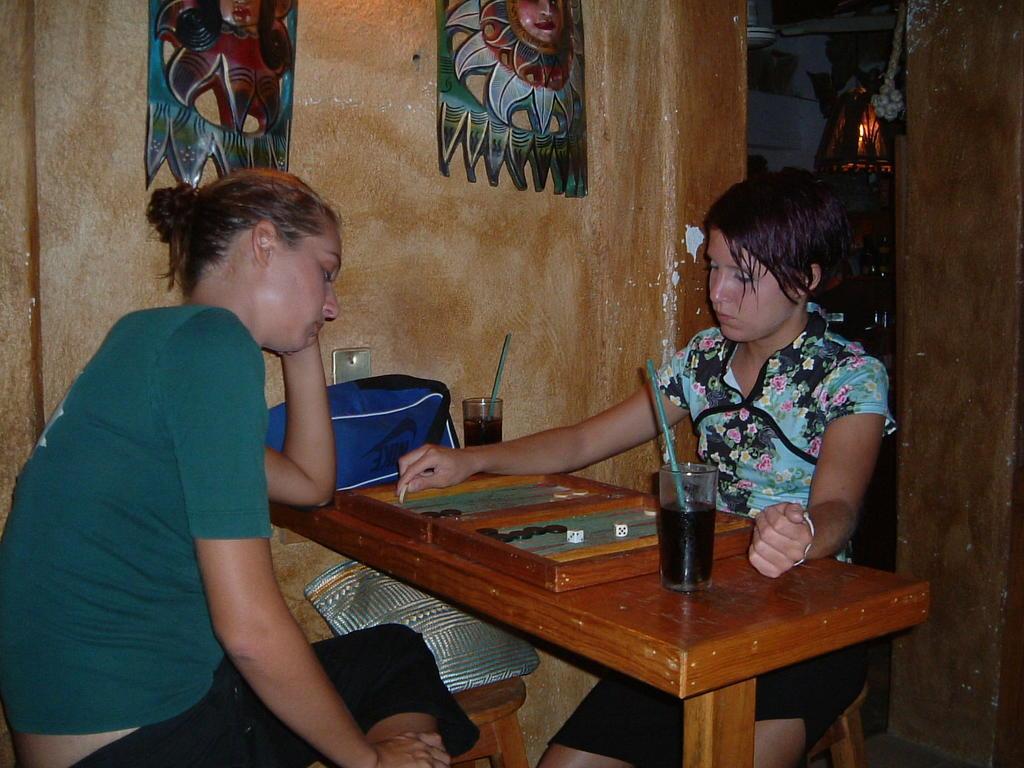In one or two sentences, can you explain what this image depicts? This image is taken in a room. There are two persons in this room. In the left side of the image there is a woman sitting on a stool placing her hands on a table. In the middle of this image there is wooden table which has a monopoly game, a glass with drink and straw and a bag on it. In the right side of the image a girl is sitting on a stool. In the middle of the image there is a wall with the carvings on it. At the most right side of the image there is a fan. 